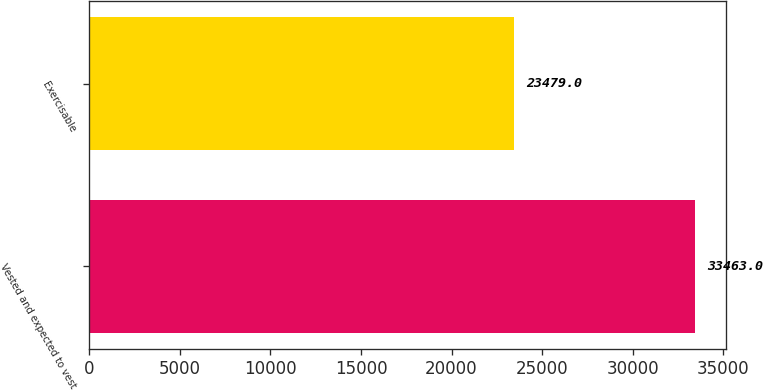Convert chart. <chart><loc_0><loc_0><loc_500><loc_500><bar_chart><fcel>Vested and expected to vest<fcel>Exercisable<nl><fcel>33463<fcel>23479<nl></chart> 